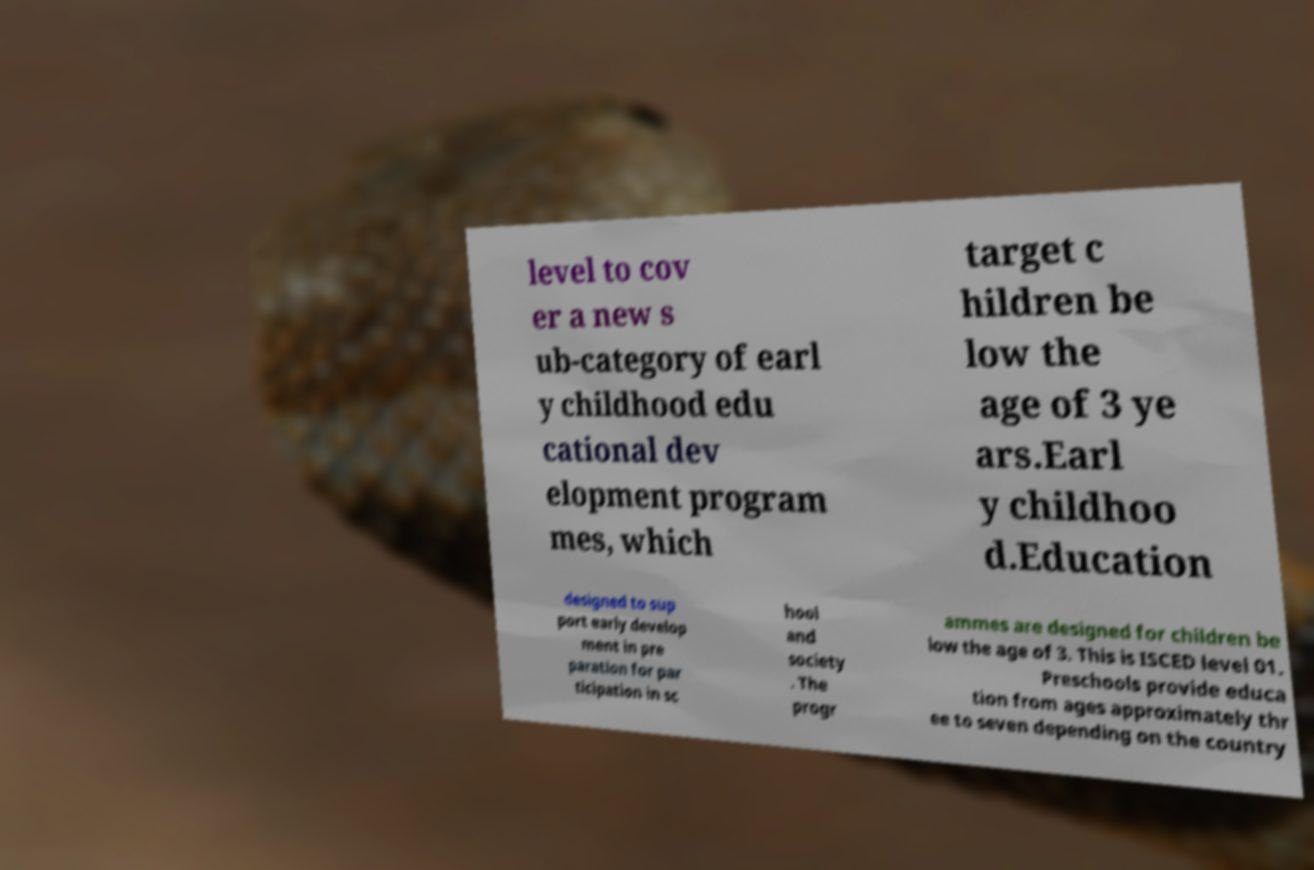Please read and relay the text visible in this image. What does it say? level to cov er a new s ub-category of earl y childhood edu cational dev elopment program mes, which target c hildren be low the age of 3 ye ars.Earl y childhoo d.Education designed to sup port early develop ment in pre paration for par ticipation in sc hool and society . The progr ammes are designed for children be low the age of 3. This is ISCED level 01. Preschools provide educa tion from ages approximately thr ee to seven depending on the country 